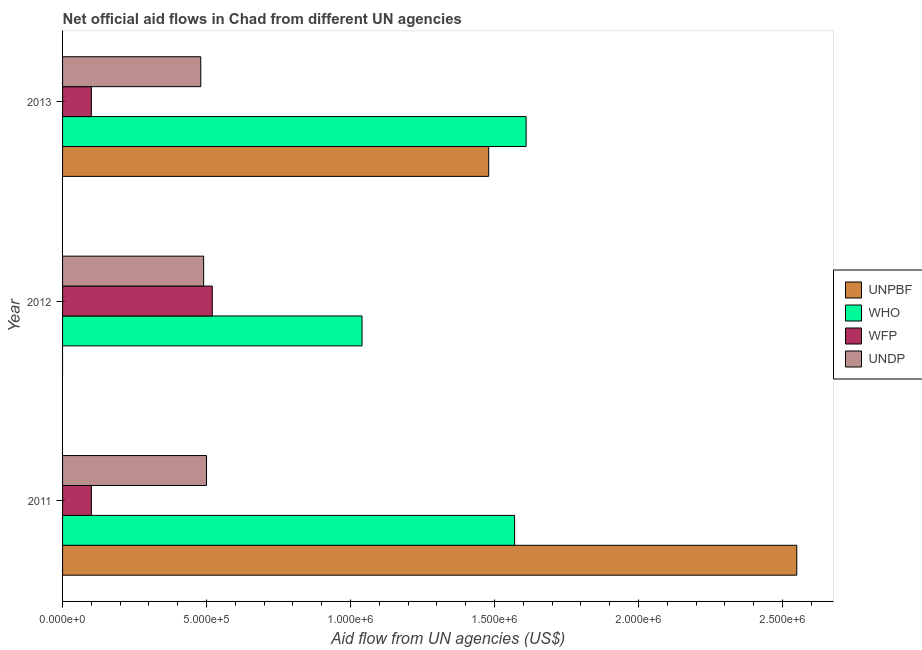How many different coloured bars are there?
Offer a very short reply. 4. Are the number of bars on each tick of the Y-axis equal?
Your answer should be very brief. No. How many bars are there on the 3rd tick from the top?
Offer a very short reply. 4. How many bars are there on the 1st tick from the bottom?
Provide a succinct answer. 4. What is the label of the 1st group of bars from the top?
Ensure brevity in your answer.  2013. In how many cases, is the number of bars for a given year not equal to the number of legend labels?
Keep it short and to the point. 1. What is the amount of aid given by unpbf in 2012?
Give a very brief answer. 0. Across all years, what is the maximum amount of aid given by unpbf?
Provide a short and direct response. 2.55e+06. Across all years, what is the minimum amount of aid given by who?
Offer a terse response. 1.04e+06. In which year was the amount of aid given by wfp maximum?
Make the answer very short. 2012. What is the total amount of aid given by wfp in the graph?
Offer a terse response. 7.20e+05. What is the difference between the amount of aid given by who in 2012 and that in 2013?
Your answer should be compact. -5.70e+05. What is the difference between the amount of aid given by undp in 2013 and the amount of aid given by wfp in 2011?
Give a very brief answer. 3.80e+05. What is the average amount of aid given by undp per year?
Provide a short and direct response. 4.90e+05. In the year 2013, what is the difference between the amount of aid given by who and amount of aid given by undp?
Offer a very short reply. 1.13e+06. In how many years, is the amount of aid given by wfp greater than 400000 US$?
Your answer should be compact. 1. What is the ratio of the amount of aid given by unpbf in 2011 to that in 2013?
Give a very brief answer. 1.72. Is the amount of aid given by undp in 2011 less than that in 2012?
Give a very brief answer. No. Is the difference between the amount of aid given by wfp in 2011 and 2013 greater than the difference between the amount of aid given by unpbf in 2011 and 2013?
Your response must be concise. No. What is the difference between the highest and the second highest amount of aid given by undp?
Provide a short and direct response. 10000. What is the difference between the highest and the lowest amount of aid given by wfp?
Provide a succinct answer. 4.20e+05. Is the sum of the amount of aid given by undp in 2011 and 2012 greater than the maximum amount of aid given by wfp across all years?
Offer a terse response. Yes. How many bars are there?
Ensure brevity in your answer.  11. Are all the bars in the graph horizontal?
Give a very brief answer. Yes. Are the values on the major ticks of X-axis written in scientific E-notation?
Provide a succinct answer. Yes. What is the title of the graph?
Provide a short and direct response. Net official aid flows in Chad from different UN agencies. What is the label or title of the X-axis?
Give a very brief answer. Aid flow from UN agencies (US$). What is the label or title of the Y-axis?
Your answer should be compact. Year. What is the Aid flow from UN agencies (US$) in UNPBF in 2011?
Keep it short and to the point. 2.55e+06. What is the Aid flow from UN agencies (US$) of WHO in 2011?
Your answer should be compact. 1.57e+06. What is the Aid flow from UN agencies (US$) in UNPBF in 2012?
Offer a very short reply. 0. What is the Aid flow from UN agencies (US$) in WHO in 2012?
Keep it short and to the point. 1.04e+06. What is the Aid flow from UN agencies (US$) of WFP in 2012?
Provide a succinct answer. 5.20e+05. What is the Aid flow from UN agencies (US$) of UNPBF in 2013?
Make the answer very short. 1.48e+06. What is the Aid flow from UN agencies (US$) in WHO in 2013?
Your answer should be compact. 1.61e+06. What is the Aid flow from UN agencies (US$) in UNDP in 2013?
Offer a terse response. 4.80e+05. Across all years, what is the maximum Aid flow from UN agencies (US$) in UNPBF?
Make the answer very short. 2.55e+06. Across all years, what is the maximum Aid flow from UN agencies (US$) in WHO?
Offer a terse response. 1.61e+06. Across all years, what is the maximum Aid flow from UN agencies (US$) of WFP?
Give a very brief answer. 5.20e+05. Across all years, what is the minimum Aid flow from UN agencies (US$) of UNPBF?
Give a very brief answer. 0. Across all years, what is the minimum Aid flow from UN agencies (US$) in WHO?
Keep it short and to the point. 1.04e+06. Across all years, what is the minimum Aid flow from UN agencies (US$) of UNDP?
Give a very brief answer. 4.80e+05. What is the total Aid flow from UN agencies (US$) of UNPBF in the graph?
Keep it short and to the point. 4.03e+06. What is the total Aid flow from UN agencies (US$) in WHO in the graph?
Offer a terse response. 4.22e+06. What is the total Aid flow from UN agencies (US$) in WFP in the graph?
Your answer should be very brief. 7.20e+05. What is the total Aid flow from UN agencies (US$) of UNDP in the graph?
Offer a very short reply. 1.47e+06. What is the difference between the Aid flow from UN agencies (US$) in WHO in 2011 and that in 2012?
Keep it short and to the point. 5.30e+05. What is the difference between the Aid flow from UN agencies (US$) of WFP in 2011 and that in 2012?
Provide a short and direct response. -4.20e+05. What is the difference between the Aid flow from UN agencies (US$) in UNDP in 2011 and that in 2012?
Provide a short and direct response. 10000. What is the difference between the Aid flow from UN agencies (US$) in UNPBF in 2011 and that in 2013?
Offer a terse response. 1.07e+06. What is the difference between the Aid flow from UN agencies (US$) in WFP in 2011 and that in 2013?
Offer a terse response. 0. What is the difference between the Aid flow from UN agencies (US$) of WHO in 2012 and that in 2013?
Offer a very short reply. -5.70e+05. What is the difference between the Aid flow from UN agencies (US$) in WFP in 2012 and that in 2013?
Your response must be concise. 4.20e+05. What is the difference between the Aid flow from UN agencies (US$) of UNPBF in 2011 and the Aid flow from UN agencies (US$) of WHO in 2012?
Provide a succinct answer. 1.51e+06. What is the difference between the Aid flow from UN agencies (US$) in UNPBF in 2011 and the Aid flow from UN agencies (US$) in WFP in 2012?
Provide a succinct answer. 2.03e+06. What is the difference between the Aid flow from UN agencies (US$) in UNPBF in 2011 and the Aid flow from UN agencies (US$) in UNDP in 2012?
Provide a short and direct response. 2.06e+06. What is the difference between the Aid flow from UN agencies (US$) of WHO in 2011 and the Aid flow from UN agencies (US$) of WFP in 2012?
Your answer should be very brief. 1.05e+06. What is the difference between the Aid flow from UN agencies (US$) of WHO in 2011 and the Aid flow from UN agencies (US$) of UNDP in 2012?
Make the answer very short. 1.08e+06. What is the difference between the Aid flow from UN agencies (US$) of WFP in 2011 and the Aid flow from UN agencies (US$) of UNDP in 2012?
Your answer should be compact. -3.90e+05. What is the difference between the Aid flow from UN agencies (US$) in UNPBF in 2011 and the Aid flow from UN agencies (US$) in WHO in 2013?
Your response must be concise. 9.40e+05. What is the difference between the Aid flow from UN agencies (US$) in UNPBF in 2011 and the Aid flow from UN agencies (US$) in WFP in 2013?
Your answer should be compact. 2.45e+06. What is the difference between the Aid flow from UN agencies (US$) of UNPBF in 2011 and the Aid flow from UN agencies (US$) of UNDP in 2013?
Provide a succinct answer. 2.07e+06. What is the difference between the Aid flow from UN agencies (US$) of WHO in 2011 and the Aid flow from UN agencies (US$) of WFP in 2013?
Provide a short and direct response. 1.47e+06. What is the difference between the Aid flow from UN agencies (US$) in WHO in 2011 and the Aid flow from UN agencies (US$) in UNDP in 2013?
Provide a short and direct response. 1.09e+06. What is the difference between the Aid flow from UN agencies (US$) of WFP in 2011 and the Aid flow from UN agencies (US$) of UNDP in 2013?
Your answer should be compact. -3.80e+05. What is the difference between the Aid flow from UN agencies (US$) in WHO in 2012 and the Aid flow from UN agencies (US$) in WFP in 2013?
Your answer should be compact. 9.40e+05. What is the difference between the Aid flow from UN agencies (US$) in WHO in 2012 and the Aid flow from UN agencies (US$) in UNDP in 2013?
Offer a very short reply. 5.60e+05. What is the average Aid flow from UN agencies (US$) in UNPBF per year?
Offer a terse response. 1.34e+06. What is the average Aid flow from UN agencies (US$) in WHO per year?
Keep it short and to the point. 1.41e+06. What is the average Aid flow from UN agencies (US$) in UNDP per year?
Keep it short and to the point. 4.90e+05. In the year 2011, what is the difference between the Aid flow from UN agencies (US$) of UNPBF and Aid flow from UN agencies (US$) of WHO?
Make the answer very short. 9.80e+05. In the year 2011, what is the difference between the Aid flow from UN agencies (US$) in UNPBF and Aid flow from UN agencies (US$) in WFP?
Keep it short and to the point. 2.45e+06. In the year 2011, what is the difference between the Aid flow from UN agencies (US$) of UNPBF and Aid flow from UN agencies (US$) of UNDP?
Your answer should be compact. 2.05e+06. In the year 2011, what is the difference between the Aid flow from UN agencies (US$) of WHO and Aid flow from UN agencies (US$) of WFP?
Keep it short and to the point. 1.47e+06. In the year 2011, what is the difference between the Aid flow from UN agencies (US$) in WHO and Aid flow from UN agencies (US$) in UNDP?
Your response must be concise. 1.07e+06. In the year 2011, what is the difference between the Aid flow from UN agencies (US$) in WFP and Aid flow from UN agencies (US$) in UNDP?
Provide a succinct answer. -4.00e+05. In the year 2012, what is the difference between the Aid flow from UN agencies (US$) in WHO and Aid flow from UN agencies (US$) in WFP?
Provide a succinct answer. 5.20e+05. In the year 2013, what is the difference between the Aid flow from UN agencies (US$) in UNPBF and Aid flow from UN agencies (US$) in WHO?
Ensure brevity in your answer.  -1.30e+05. In the year 2013, what is the difference between the Aid flow from UN agencies (US$) in UNPBF and Aid flow from UN agencies (US$) in WFP?
Provide a short and direct response. 1.38e+06. In the year 2013, what is the difference between the Aid flow from UN agencies (US$) in WHO and Aid flow from UN agencies (US$) in WFP?
Offer a very short reply. 1.51e+06. In the year 2013, what is the difference between the Aid flow from UN agencies (US$) in WHO and Aid flow from UN agencies (US$) in UNDP?
Offer a very short reply. 1.13e+06. In the year 2013, what is the difference between the Aid flow from UN agencies (US$) of WFP and Aid flow from UN agencies (US$) of UNDP?
Your answer should be compact. -3.80e+05. What is the ratio of the Aid flow from UN agencies (US$) of WHO in 2011 to that in 2012?
Provide a short and direct response. 1.51. What is the ratio of the Aid flow from UN agencies (US$) of WFP in 2011 to that in 2012?
Make the answer very short. 0.19. What is the ratio of the Aid flow from UN agencies (US$) of UNDP in 2011 to that in 2012?
Offer a terse response. 1.02. What is the ratio of the Aid flow from UN agencies (US$) of UNPBF in 2011 to that in 2013?
Give a very brief answer. 1.72. What is the ratio of the Aid flow from UN agencies (US$) of WHO in 2011 to that in 2013?
Provide a short and direct response. 0.98. What is the ratio of the Aid flow from UN agencies (US$) of UNDP in 2011 to that in 2013?
Ensure brevity in your answer.  1.04. What is the ratio of the Aid flow from UN agencies (US$) in WHO in 2012 to that in 2013?
Your answer should be very brief. 0.65. What is the ratio of the Aid flow from UN agencies (US$) in WFP in 2012 to that in 2013?
Give a very brief answer. 5.2. What is the ratio of the Aid flow from UN agencies (US$) in UNDP in 2012 to that in 2013?
Your answer should be compact. 1.02. What is the difference between the highest and the second highest Aid flow from UN agencies (US$) in WHO?
Your response must be concise. 4.00e+04. What is the difference between the highest and the second highest Aid flow from UN agencies (US$) of WFP?
Keep it short and to the point. 4.20e+05. What is the difference between the highest and the lowest Aid flow from UN agencies (US$) of UNPBF?
Provide a short and direct response. 2.55e+06. What is the difference between the highest and the lowest Aid flow from UN agencies (US$) of WHO?
Your answer should be compact. 5.70e+05. What is the difference between the highest and the lowest Aid flow from UN agencies (US$) in WFP?
Your answer should be compact. 4.20e+05. 